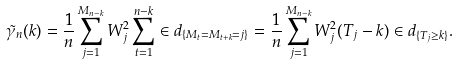<formula> <loc_0><loc_0><loc_500><loc_500>\tilde { \gamma } _ { n } ( k ) = \frac { 1 } { n } \sum _ { j = 1 } ^ { M _ { n - k } } W _ { j } ^ { 2 } \sum _ { t = 1 } ^ { n - k } \in d _ { \{ M _ { t } = M _ { t + k } = j \} } = \frac { 1 } { n } \sum _ { j = 1 } ^ { M _ { n - k } } W _ { j } ^ { 2 } ( T _ { j } - k ) \in d _ { \{ T _ { j } \geq k \} } .</formula> 